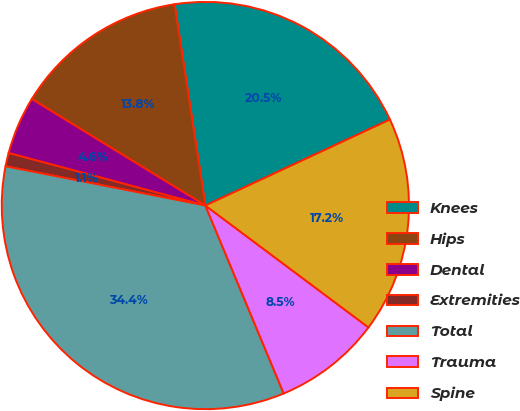Convert chart to OTSL. <chart><loc_0><loc_0><loc_500><loc_500><pie_chart><fcel>Knees<fcel>Hips<fcel>Dental<fcel>Extremities<fcel>Total<fcel>Trauma<fcel>Spine<nl><fcel>20.48%<fcel>13.82%<fcel>4.61%<fcel>1.06%<fcel>34.37%<fcel>8.5%<fcel>17.15%<nl></chart> 